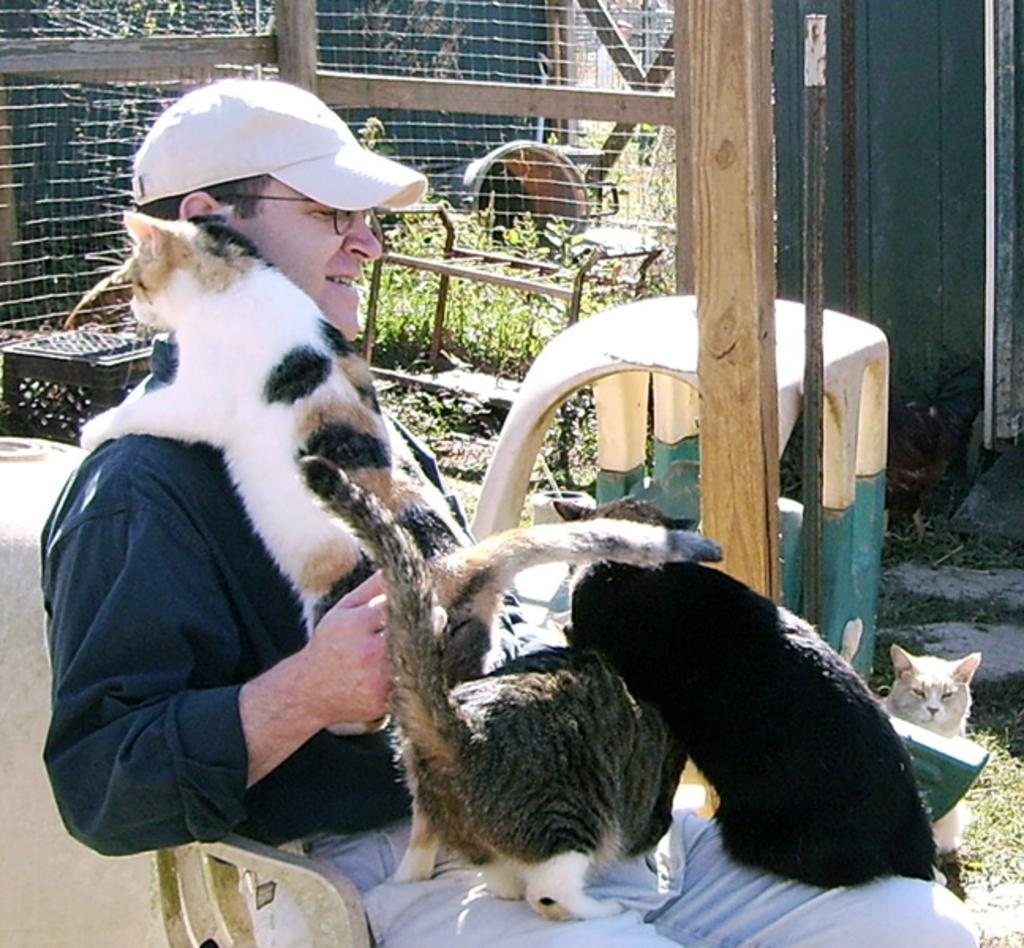What is the man in the image doing? The man is sitting on a chair in the image. What animals are present in the image? There are cats in the image. What accessories is the man wearing? The man is wearing a cap and has spectacles. What can be seen in the background of the image? There is a fence in the background of the image. Where is the basin located in the image? There is no basin present in the image. What type of fiction is the man reading in the image? The image does not show the man reading any fiction; he is simply sitting on a chair. 